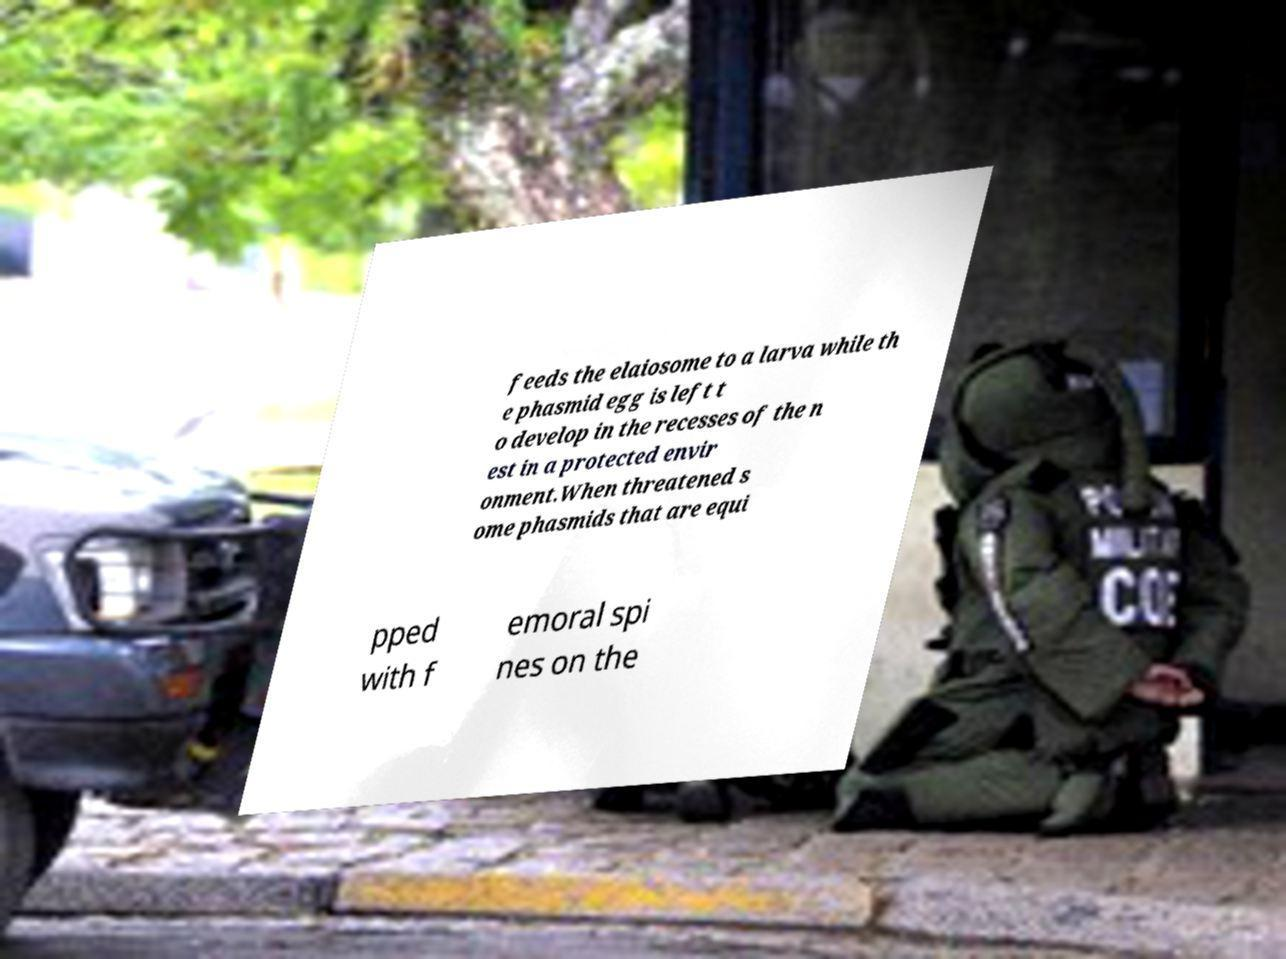For documentation purposes, I need the text within this image transcribed. Could you provide that? feeds the elaiosome to a larva while th e phasmid egg is left t o develop in the recesses of the n est in a protected envir onment.When threatened s ome phasmids that are equi pped with f emoral spi nes on the 